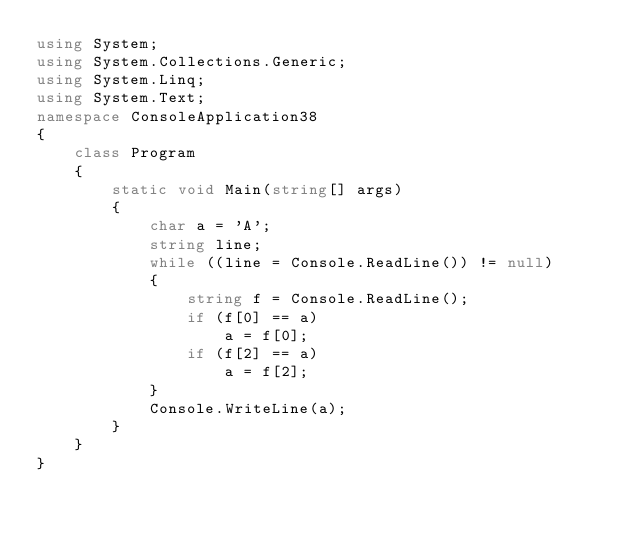Convert code to text. <code><loc_0><loc_0><loc_500><loc_500><_C#_>using System;
using System.Collections.Generic;
using System.Linq;
using System.Text;
namespace ConsoleApplication38
{
    class Program
    {
        static void Main(string[] args)
        {
            char a = 'A';
            string line;
            while ((line = Console.ReadLine()) != null)
            {
                string f = Console.ReadLine();
                if (f[0] == a)
                    a = f[0];
                if (f[2] == a)
                    a = f[2];
            }
            Console.WriteLine(a);
        }
    }
}</code> 